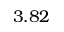Convert formula to latex. <formula><loc_0><loc_0><loc_500><loc_500>3 . 8 2</formula> 